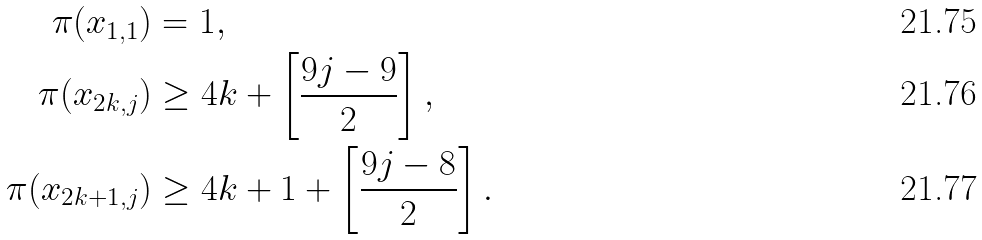<formula> <loc_0><loc_0><loc_500><loc_500>\pi ( x _ { 1 , 1 } ) & = 1 , \\ \pi ( x _ { 2 k , j } ) & \geq 4 k + \left [ \frac { 9 j - 9 } { 2 } \right ] , \\ \pi ( x _ { 2 k + 1 , j } ) & \geq 4 k + 1 + \left [ \frac { 9 j - 8 } { 2 } \right ] .</formula> 